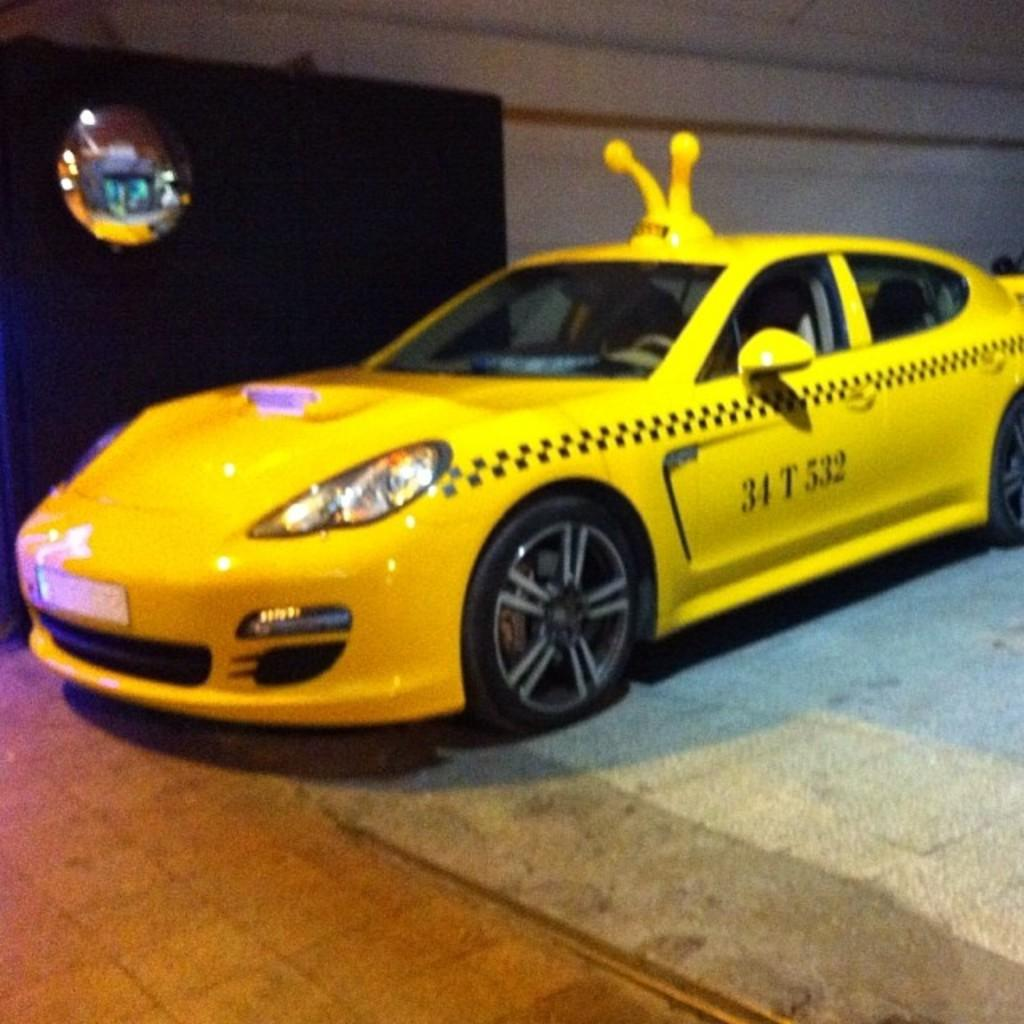<image>
Present a compact description of the photo's key features. A yellow car with 34 T 532 written on the side. 